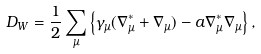<formula> <loc_0><loc_0><loc_500><loc_500>D _ { W } = \frac { 1 } { 2 } \sum _ { \mu } \left \{ \gamma _ { \mu } ( \nabla _ { \mu } ^ { * } + \nabla _ { \mu } ) - a \nabla _ { \mu } ^ { * } \nabla _ { \mu } \right \} ,</formula> 